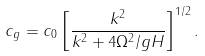<formula> <loc_0><loc_0><loc_500><loc_500>c _ { g } = c _ { 0 } \left [ \frac { k ^ { 2 } } { k ^ { 2 } + 4 \Omega ^ { 2 } / g H } \right ] ^ { 1 / 2 } .</formula> 